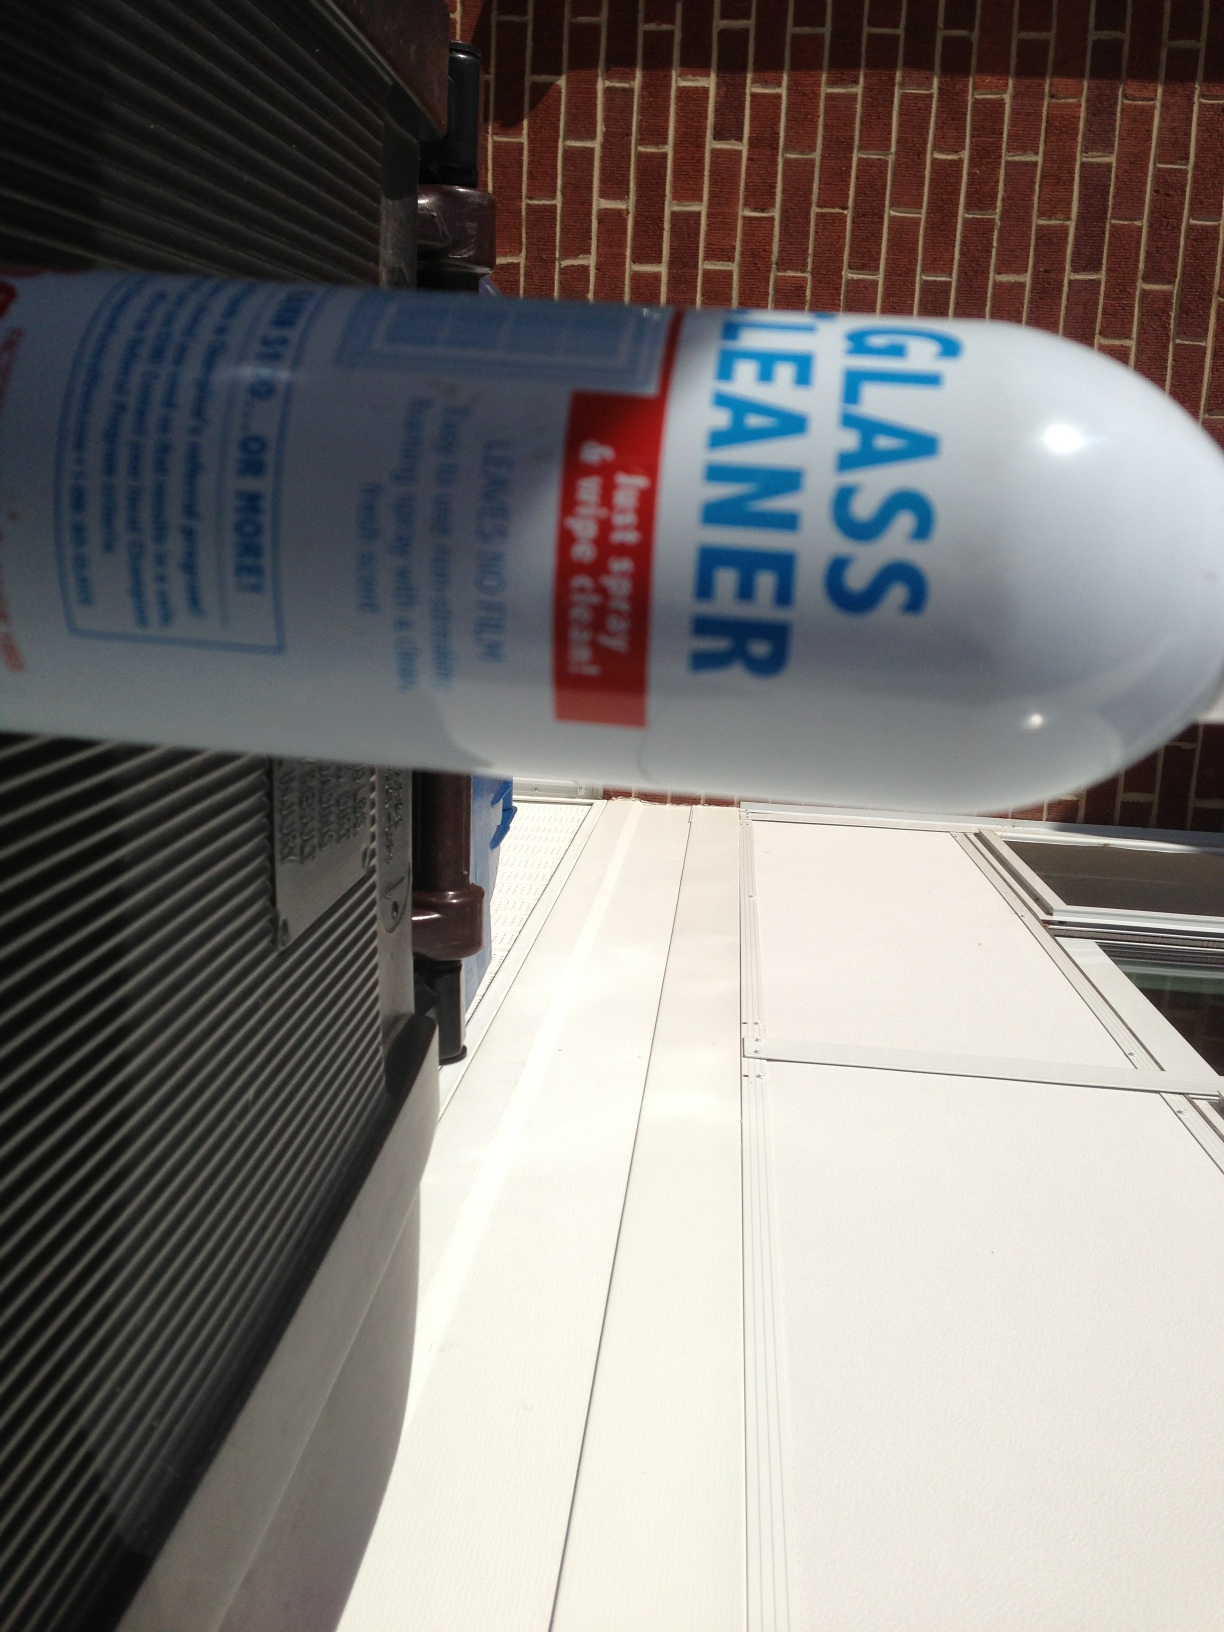Can you tell me how this product should be used? Certainly! Glass cleaner should be sprayed directly onto the glass surface from a distance of about 6 to 8 inches. Then, wipe the surface with a clean, lint-free cloth or paper towel in a circular motion until dry, ensuring a streak-free finish. It's important to avoid using glass cleaner on hot surfaces or in direct sunlight to prevent streaking. 